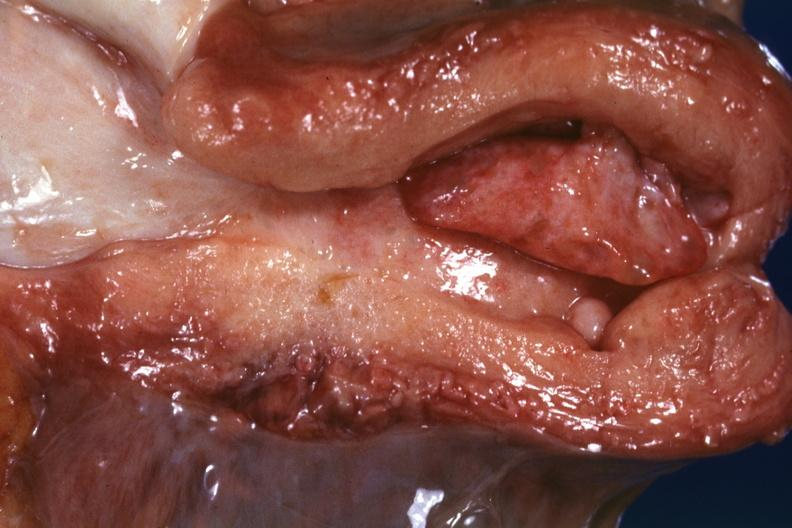does retroperitoneal liposarcoma show large endometrial polyp probably senile type?
Answer the question using a single word or phrase. No 